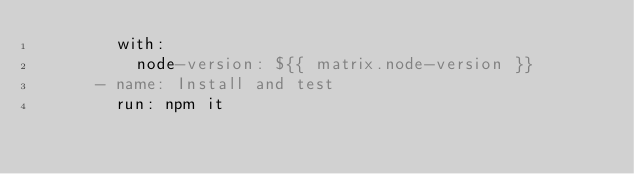<code> <loc_0><loc_0><loc_500><loc_500><_YAML_>        with:
          node-version: ${{ matrix.node-version }}
      - name: Install and test
        run: npm it
</code> 